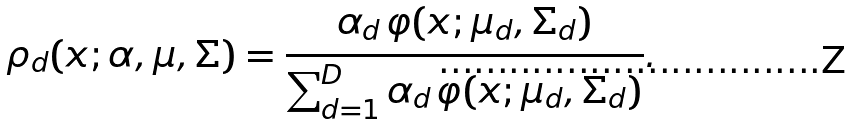<formula> <loc_0><loc_0><loc_500><loc_500>\rho _ { d } ( x ; \alpha , \mu , \Sigma ) = \frac { \alpha _ { d } \, \varphi ( x ; \mu _ { d } , \Sigma _ { d } ) } { \sum _ { d = 1 } ^ { D } \alpha _ { d } \, \varphi ( x ; \mu _ { d } , \Sigma _ { d } ) } .</formula> 